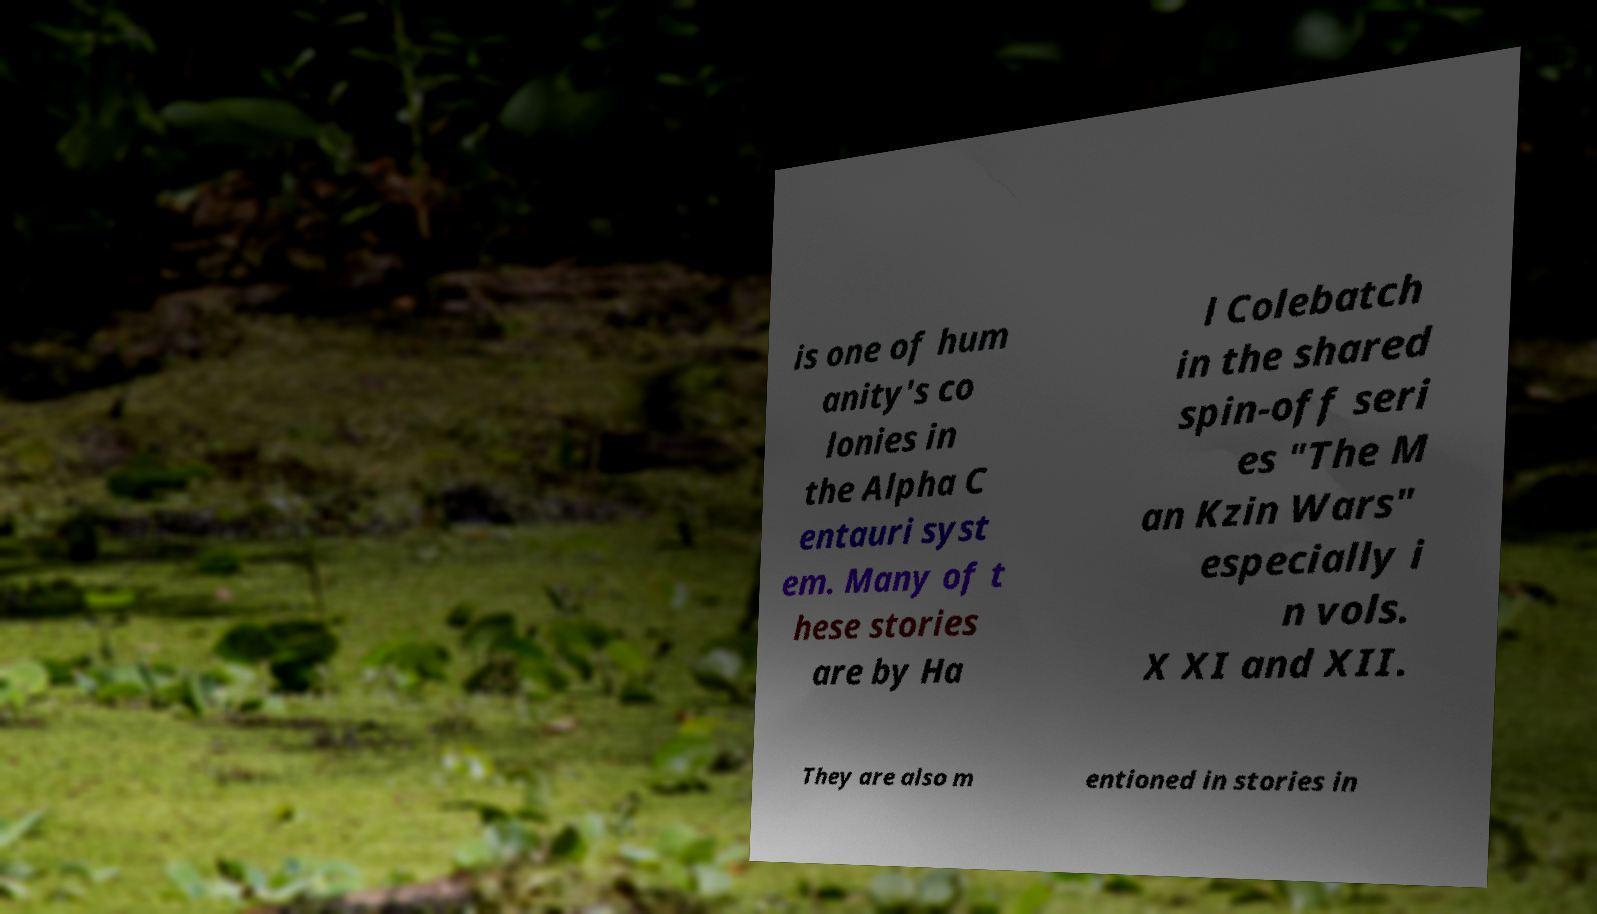Could you extract and type out the text from this image? is one of hum anity's co lonies in the Alpha C entauri syst em. Many of t hese stories are by Ha l Colebatch in the shared spin-off seri es "The M an Kzin Wars" especially i n vols. X XI and XII. They are also m entioned in stories in 